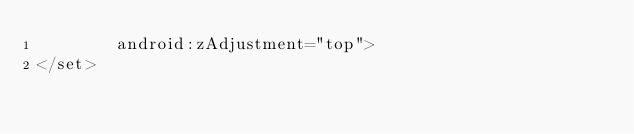Convert code to text. <code><loc_0><loc_0><loc_500><loc_500><_XML_>        android:zAdjustment="top">
</set>
</code> 